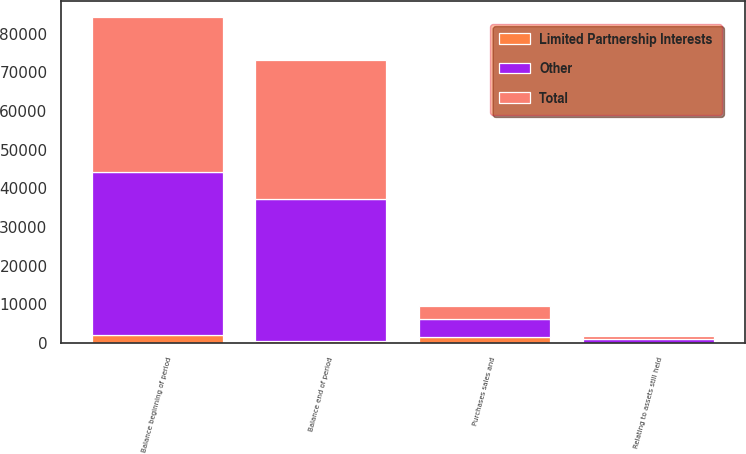Convert chart to OTSL. <chart><loc_0><loc_0><loc_500><loc_500><stacked_bar_chart><ecel><fcel>Balance beginning of period<fcel>Relating to assets still held<fcel>Purchases sales and<fcel>Balance end of period<nl><fcel>Other<fcel>42127<fcel>820<fcel>4725<fcel>36582<nl><fcel>Total<fcel>40016<fcel>930<fcel>3132<fcel>35954<nl><fcel>Limited Partnership Interests<fcel>2111<fcel>110<fcel>1593<fcel>628<nl></chart> 